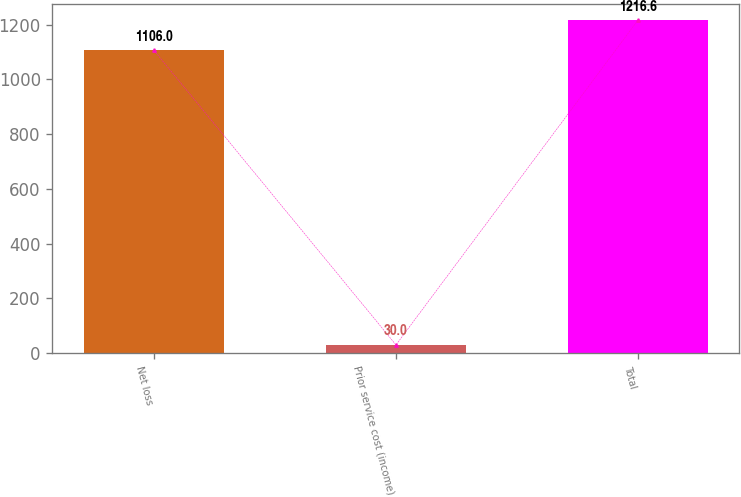Convert chart to OTSL. <chart><loc_0><loc_0><loc_500><loc_500><bar_chart><fcel>Net loss<fcel>Prior service cost (income)<fcel>Total<nl><fcel>1106<fcel>30<fcel>1216.6<nl></chart> 